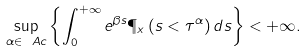<formula> <loc_0><loc_0><loc_500><loc_500>\sup _ { \alpha \in \ A c } \left \{ \int _ { 0 } ^ { + \infty } { e ^ { \beta s } \P _ { x } \left ( s < \tau ^ { \alpha } \right ) d s } \right \} < + \infty .</formula> 